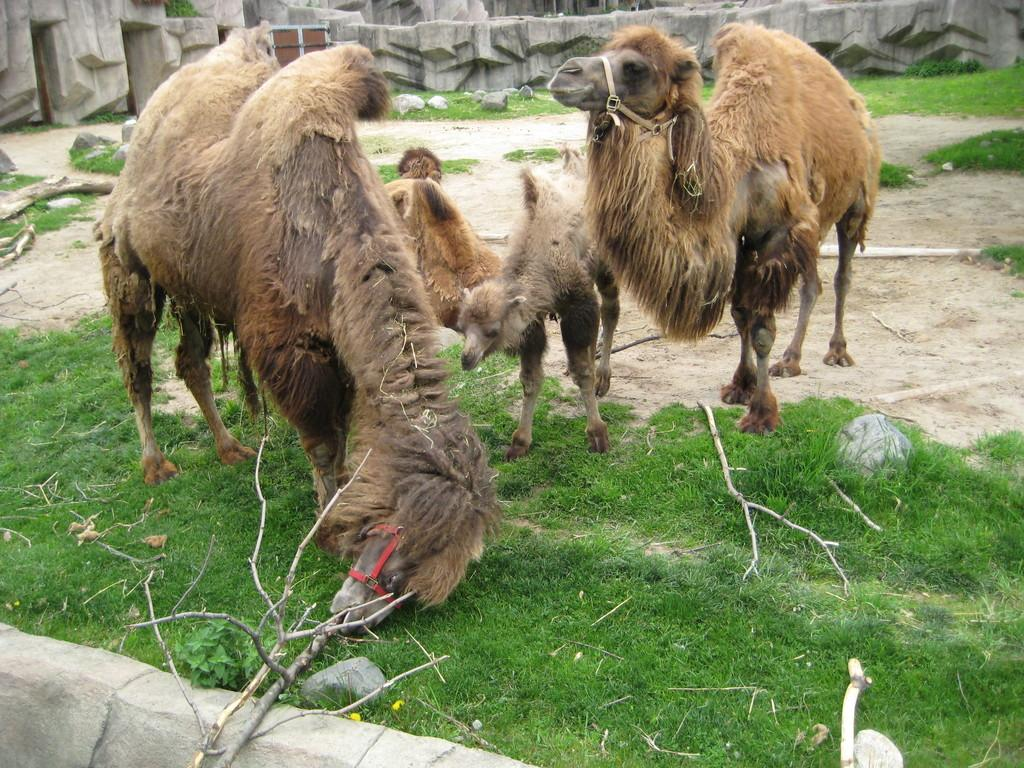What type of living organisms can be seen in the image? There are animals in the image. What color are the animals in the image? The animals are brown in color. What type of vegetation is visible in the image? There is grass visible in the image. What other objects can be seen in the image besides the animals and grass? There are sticks in the image. What can be seen in the background of the image? There are rocks in the background of the image. How many kittens are playing with the toy in the image? There is no toy or kittens present in the image; it features brown animals and other objects. What type of pig can be seen in the image? There is no pig present in the image. 